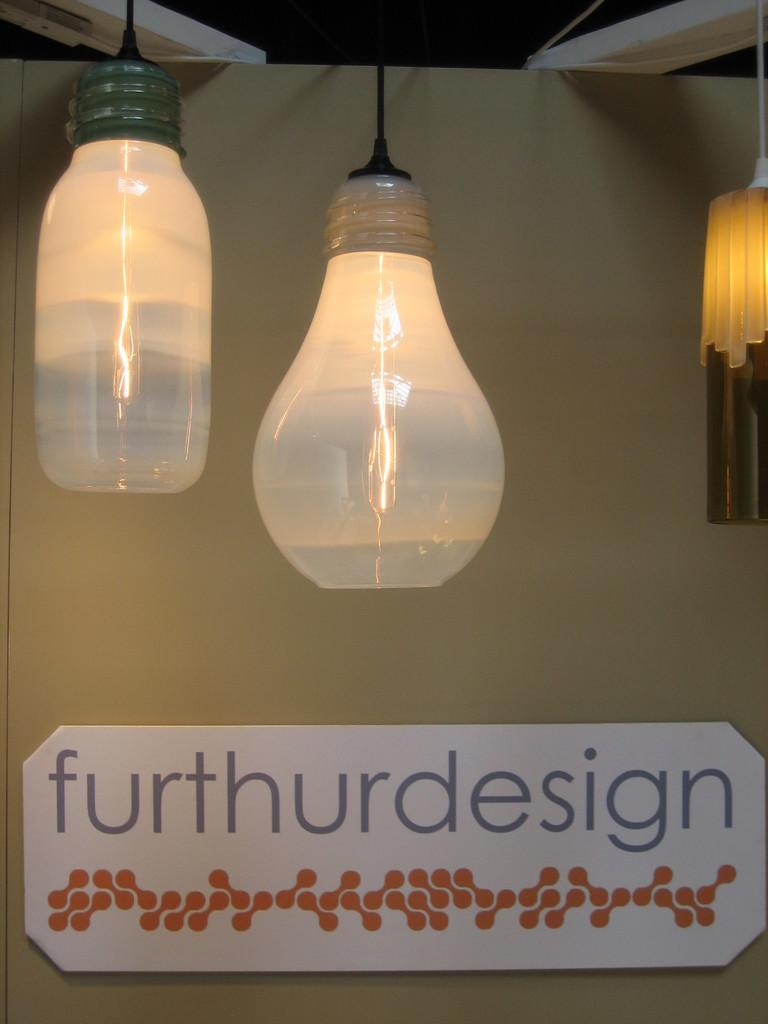<image>
Give a short and clear explanation of the subsequent image. A furthurdesign sign is hung below two lights. 